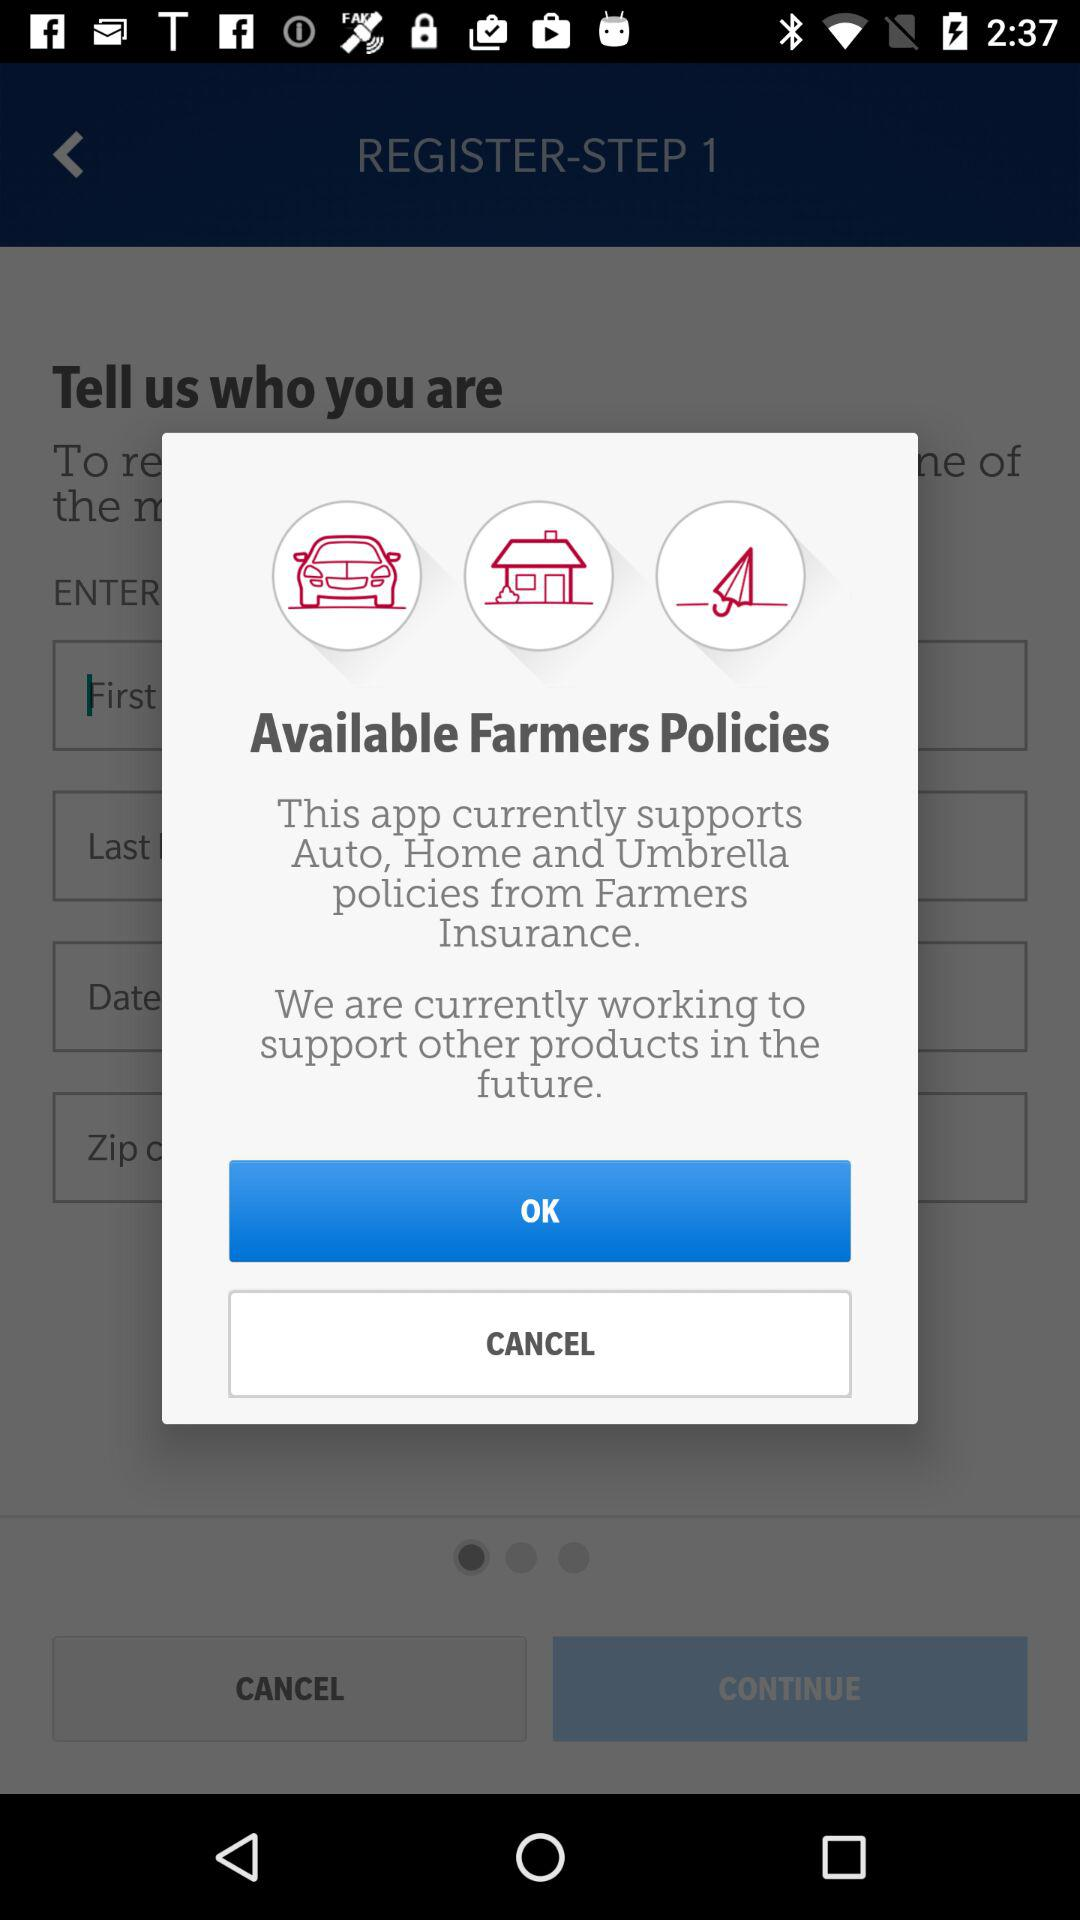How many policies are supported by the app?
Answer the question using a single word or phrase. 3 